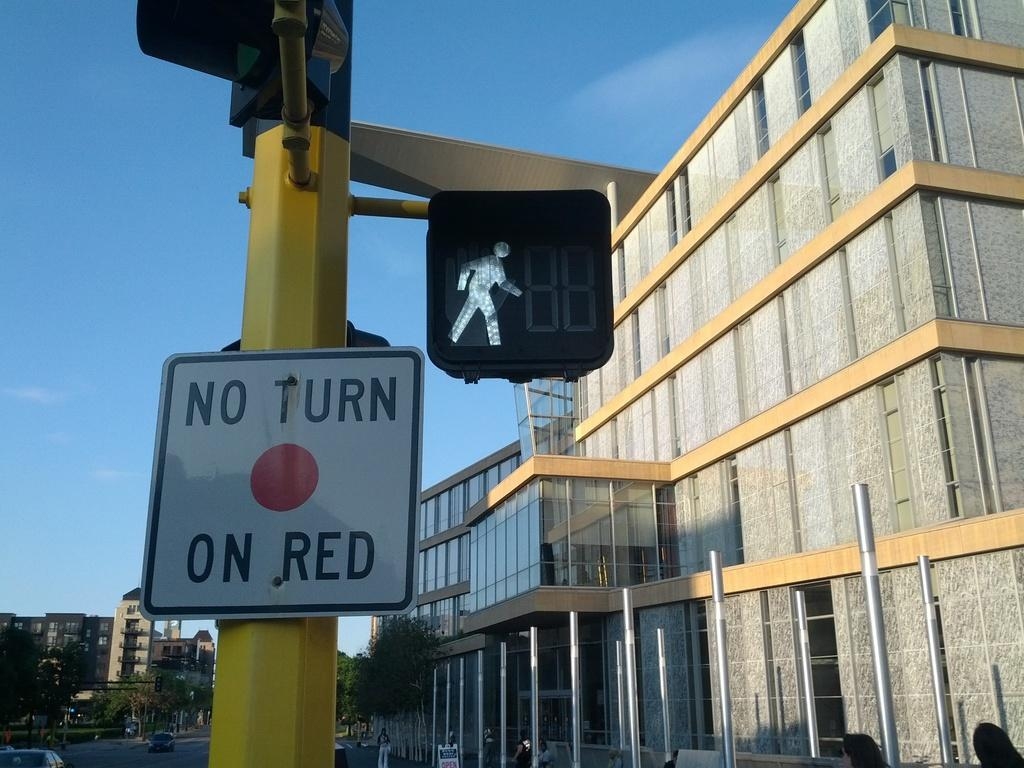<image>
Share a concise interpretation of the image provided. A yellow pole has the sign that reads no turn on red in black text on it. 